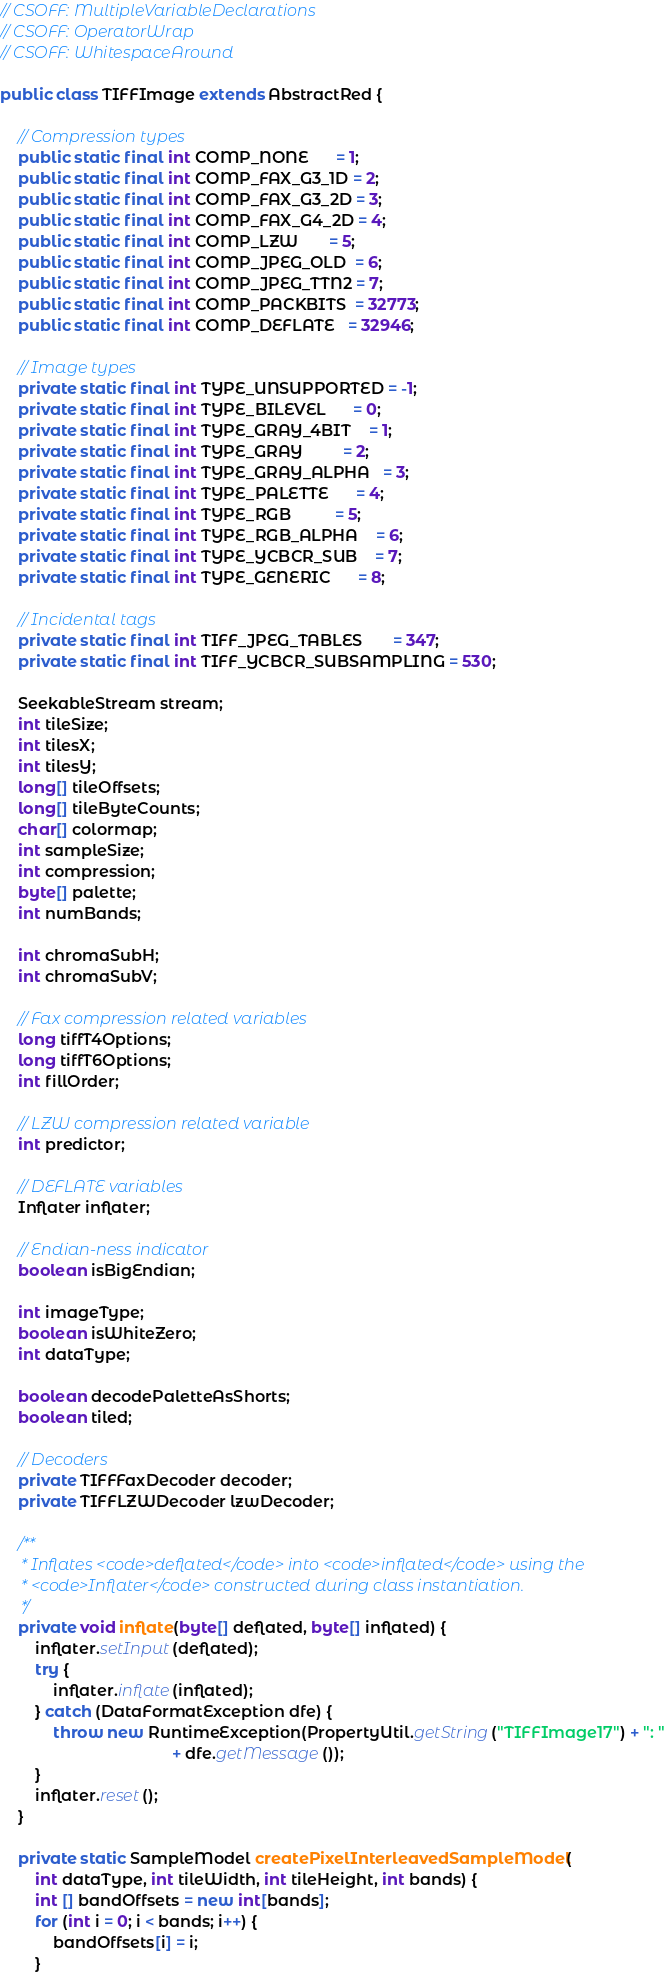<code> <loc_0><loc_0><loc_500><loc_500><_Java_>// CSOFF: MultipleVariableDeclarations
// CSOFF: OperatorWrap
// CSOFF: WhitespaceAround

public class TIFFImage extends AbstractRed {

    // Compression types
    public static final int COMP_NONE      = 1;
    public static final int COMP_FAX_G3_1D = 2;
    public static final int COMP_FAX_G3_2D = 3;
    public static final int COMP_FAX_G4_2D = 4;
    public static final int COMP_LZW       = 5;
    public static final int COMP_JPEG_OLD  = 6;
    public static final int COMP_JPEG_TTN2 = 7;
    public static final int COMP_PACKBITS  = 32773;
    public static final int COMP_DEFLATE   = 32946;

    // Image types
    private static final int TYPE_UNSUPPORTED = -1;
    private static final int TYPE_BILEVEL      = 0;
    private static final int TYPE_GRAY_4BIT    = 1;
    private static final int TYPE_GRAY         = 2;
    private static final int TYPE_GRAY_ALPHA   = 3;
    private static final int TYPE_PALETTE      = 4;
    private static final int TYPE_RGB          = 5;
    private static final int TYPE_RGB_ALPHA    = 6;
    private static final int TYPE_YCBCR_SUB    = 7;
    private static final int TYPE_GENERIC      = 8;

    // Incidental tags
    private static final int TIFF_JPEG_TABLES       = 347;
    private static final int TIFF_YCBCR_SUBSAMPLING = 530;

    SeekableStream stream;
    int tileSize;
    int tilesX;
    int tilesY;
    long[] tileOffsets;
    long[] tileByteCounts;
    char[] colormap;
    int sampleSize;
    int compression;
    byte[] palette;
    int numBands;

    int chromaSubH;
    int chromaSubV;

    // Fax compression related variables
    long tiffT4Options;
    long tiffT6Options;
    int fillOrder;

    // LZW compression related variable
    int predictor;

    // DEFLATE variables
    Inflater inflater;

    // Endian-ness indicator
    boolean isBigEndian;

    int imageType;
    boolean isWhiteZero;
    int dataType;

    boolean decodePaletteAsShorts;
    boolean tiled;

    // Decoders
    private TIFFFaxDecoder decoder;
    private TIFFLZWDecoder lzwDecoder;

    /**
     * Inflates <code>deflated</code> into <code>inflated</code> using the
     * <code>Inflater</code> constructed during class instantiation.
     */
    private void inflate(byte[] deflated, byte[] inflated) {
        inflater.setInput(deflated);
        try {
            inflater.inflate(inflated);
        } catch (DataFormatException dfe) {
            throw new RuntimeException(PropertyUtil.getString("TIFFImage17") + ": "
                                       + dfe.getMessage());
        }
        inflater.reset();
    }

    private static SampleModel createPixelInterleavedSampleModel(
        int dataType, int tileWidth, int tileHeight, int bands) {
        int [] bandOffsets = new int[bands];
        for (int i = 0; i < bands; i++) {
            bandOffsets[i] = i;
        }</code> 